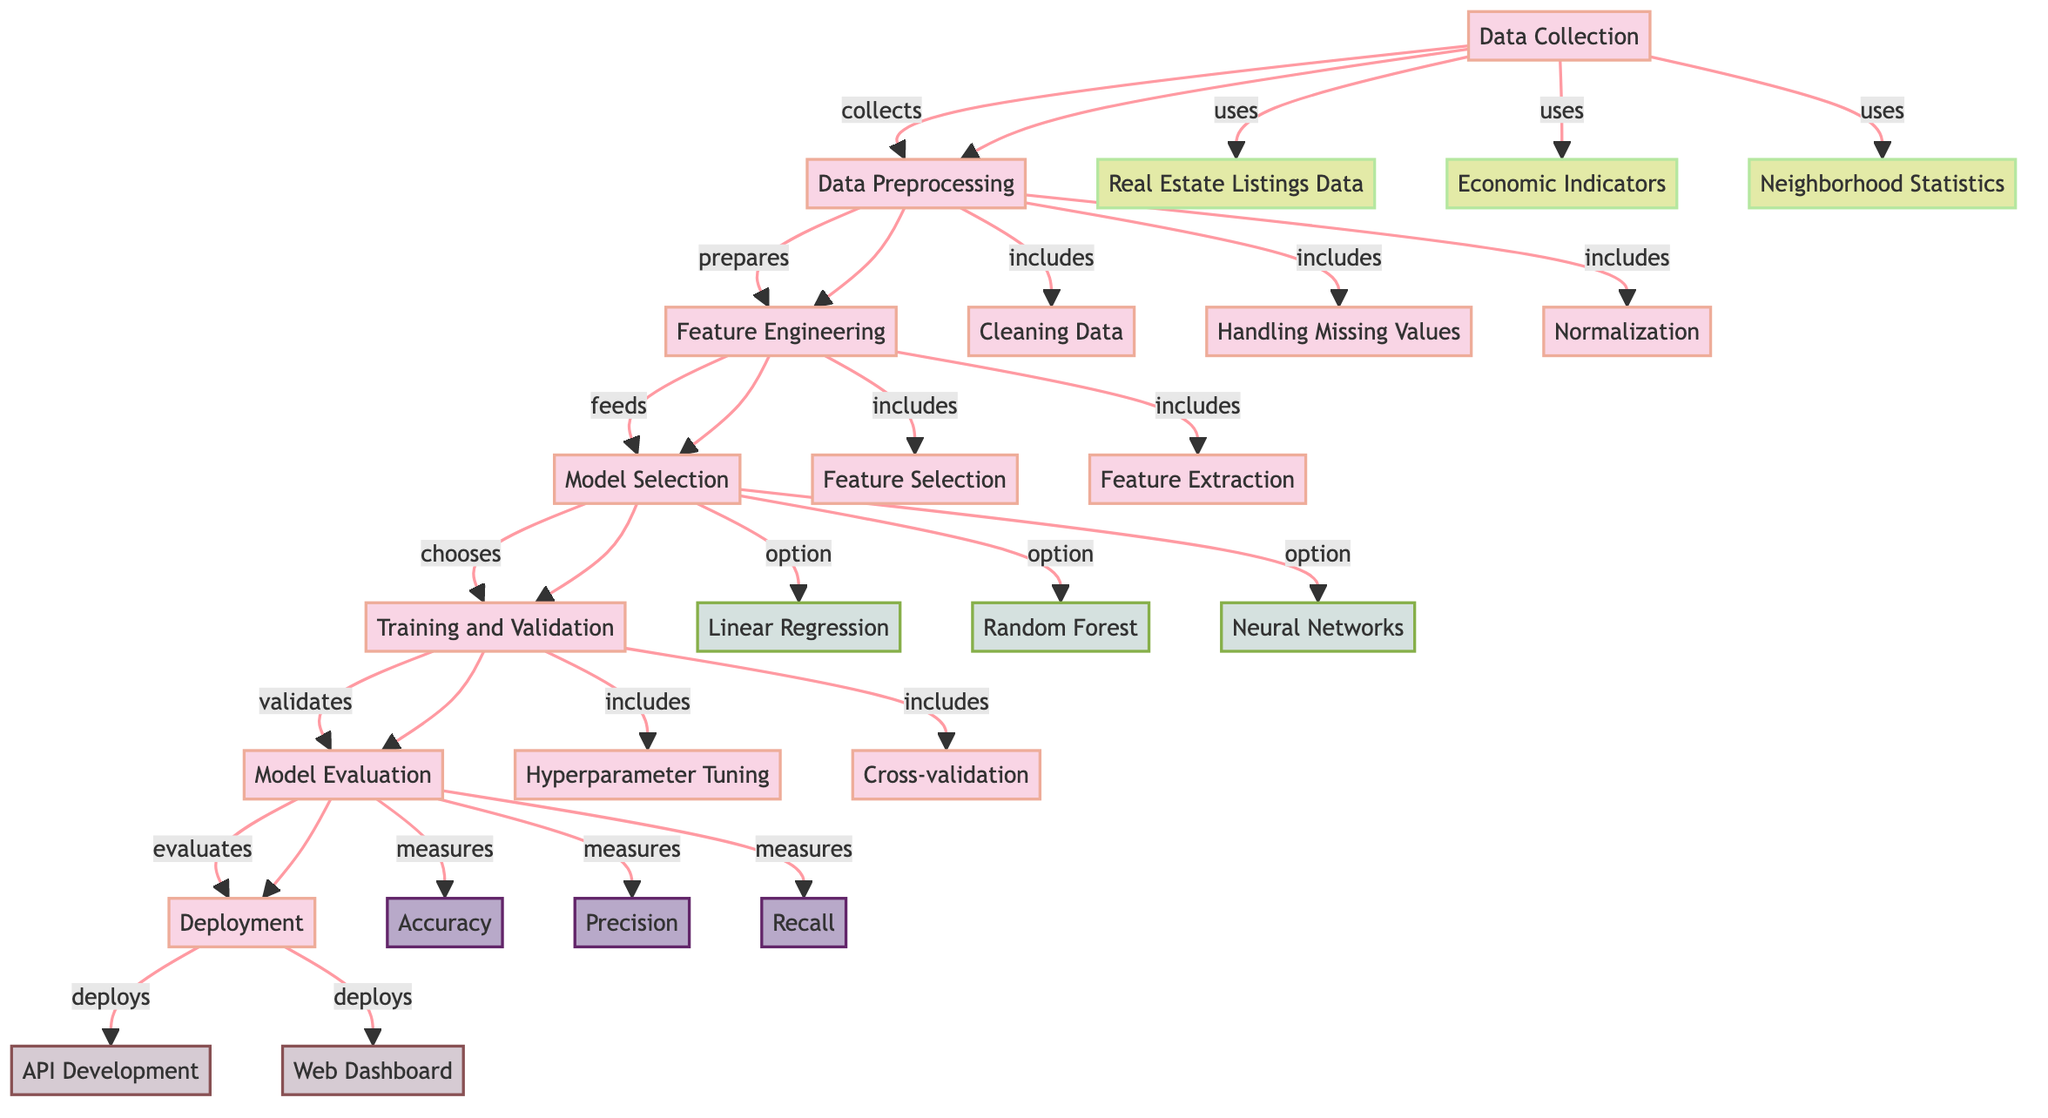What is the first node in the diagram? The first node in the diagram is labeled "Data Collection", which indicates the initial step in the process of predicting property market trends.
Answer: Data Collection How many models are included in the model selection phase? In the model selection phase, there are three models listed: Linear Regression, Random Forest, and Neural Networks, making a total of three models considered for selection.
Answer: Three What process follows data preprocessing? The process that follows data preprocessing is feature engineering, which focuses on extracting and selecting relevant features for the model.
Answer: Feature Engineering Which metric is used to evaluate the model's performance? The metrics used to evaluate the model's performance are accuracy, precision, and recall, which together measure different aspects of the model's predictive quality.
Answer: Accuracy, Precision, Recall What comes after model evaluation in the diagram? After model evaluation, the next step is deployment, indicating that the model is ready to be implemented and used in real scenarios.
Answer: Deployment Which data sources are utilized in the data collection phase? The data sources utilized in the data collection phase are Real Estate Listings Data, Economic Indicators, and Neighborhood Statistics, which provide comprehensive data for training the model.
Answer: Real Estate Listings Data, Economic Indicators, Neighborhood Statistics What is the purpose of cross-validation in the training phase? The purpose of cross-validation in the training phase is to validate the model's performance by dividing the dataset into subsets and ensuring that the model generalizes well to new data.
Answer: Validate performance How does model evaluation relate to accuracy? Model evaluation involves measuring various metrics, including accuracy, which quantifies how well the model correctly predicts the outcomes based on the validation dataset.
Answer: Evaluates correctness What node type follows the feature extraction process? The node type that follows the feature extraction process is model selection, which involves choosing the appropriate model based on the engineered features.
Answer: Model Selection 